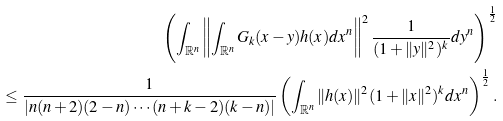Convert formula to latex. <formula><loc_0><loc_0><loc_500><loc_500>\left ( \int _ { \mathbb { R } ^ { n } } \left \| \int _ { \mathbb { R } ^ { n } } G _ { k } ( x - y ) h ( x ) d x ^ { n } \right \| ^ { 2 } \frac { 1 } { ( 1 + \| y \| ^ { 2 } ) ^ { k } } d y ^ { n } \right ) ^ { \frac { 1 } { 2 } } \\ \leq \frac { 1 } { | n ( n + 2 ) ( 2 - n ) \cdots ( n + k - 2 ) ( k - n ) | } \left ( \int _ { \mathbb { R } ^ { n } } \| h ( x ) \| ^ { 2 } ( 1 + \| x \| ^ { 2 } ) ^ { k } d x ^ { n } \right ) ^ { \frac { 1 } { 2 } } .</formula> 